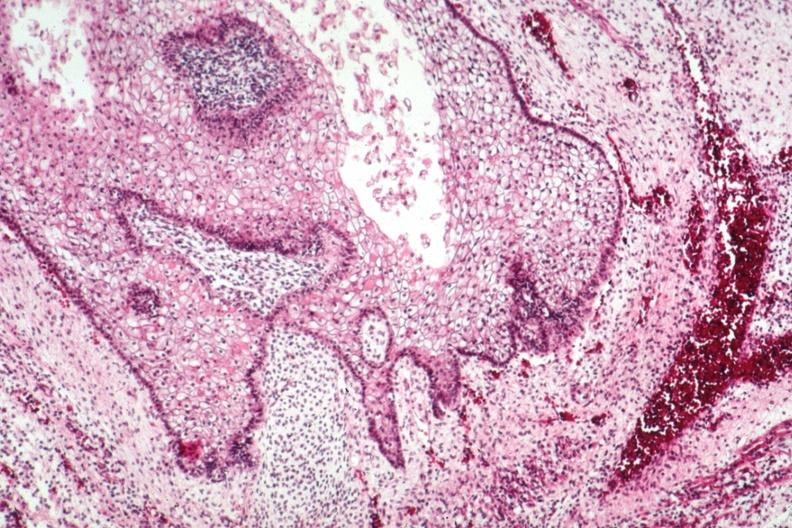what is present?
Answer the question using a single word or phrase. Sacrococcygeal teratoma 